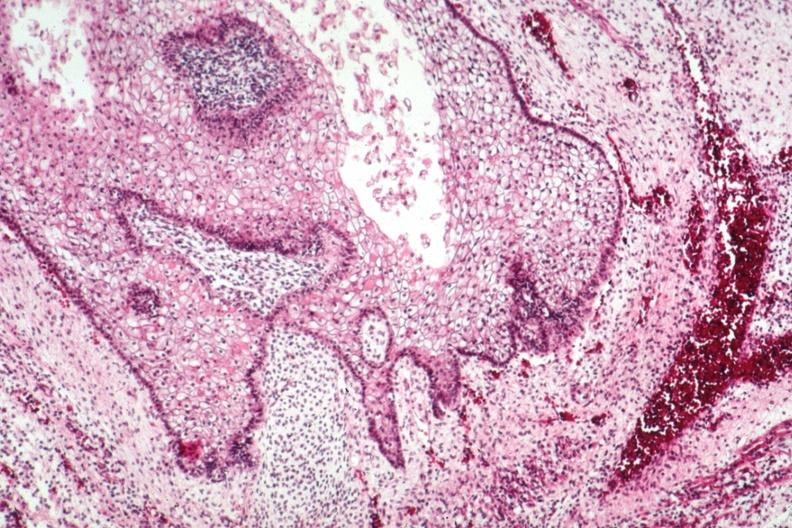what is present?
Answer the question using a single word or phrase. Sacrococcygeal teratoma 